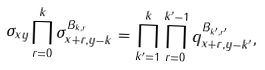<formula> <loc_0><loc_0><loc_500><loc_500>\sigma _ { x y } \prod _ { r = 0 } ^ { k } \sigma _ { x + r , y - k } ^ { B _ { k , r } } = \prod _ { k ^ { \prime } = 1 } ^ { k } \prod _ { r = 0 } ^ { k ^ { \prime } - 1 } q _ { x + r , y - k ^ { \prime } } ^ { B _ { k ^ { \prime } , r ^ { \prime } } } ,</formula> 